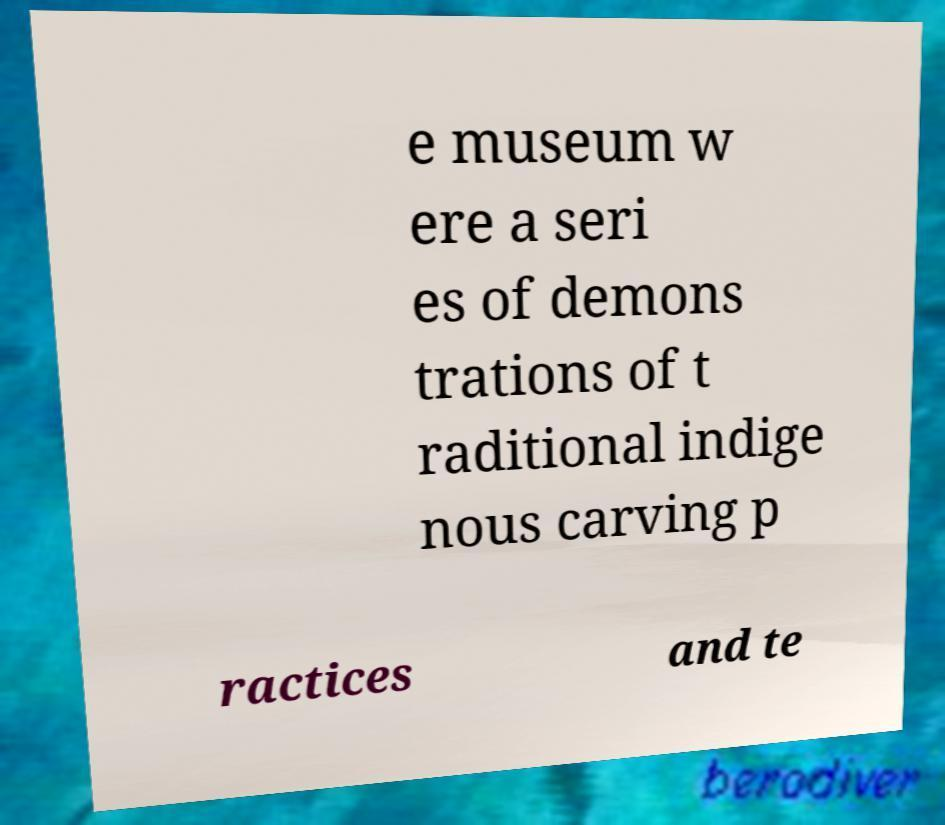Please read and relay the text visible in this image. What does it say? e museum w ere a seri es of demons trations of t raditional indige nous carving p ractices and te 